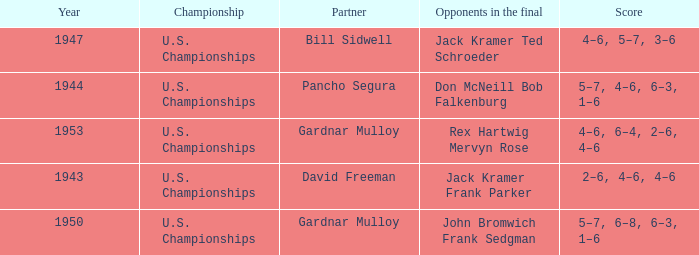Which Opponents in the final have a Score of 4–6, 6–4, 2–6, 4–6? Rex Hartwig Mervyn Rose. 